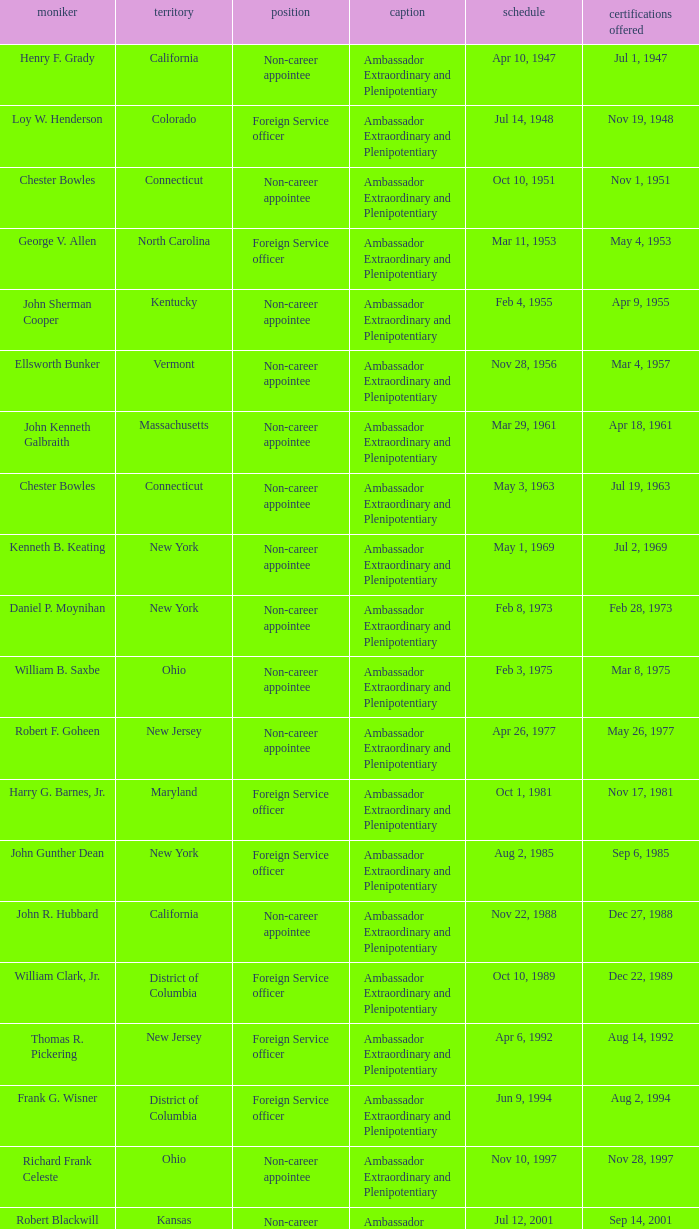What day was the appointment when Credentials Presented was jul 2, 1969? May 1, 1969. 